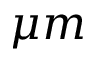Convert formula to latex. <formula><loc_0><loc_0><loc_500><loc_500>\mu m</formula> 